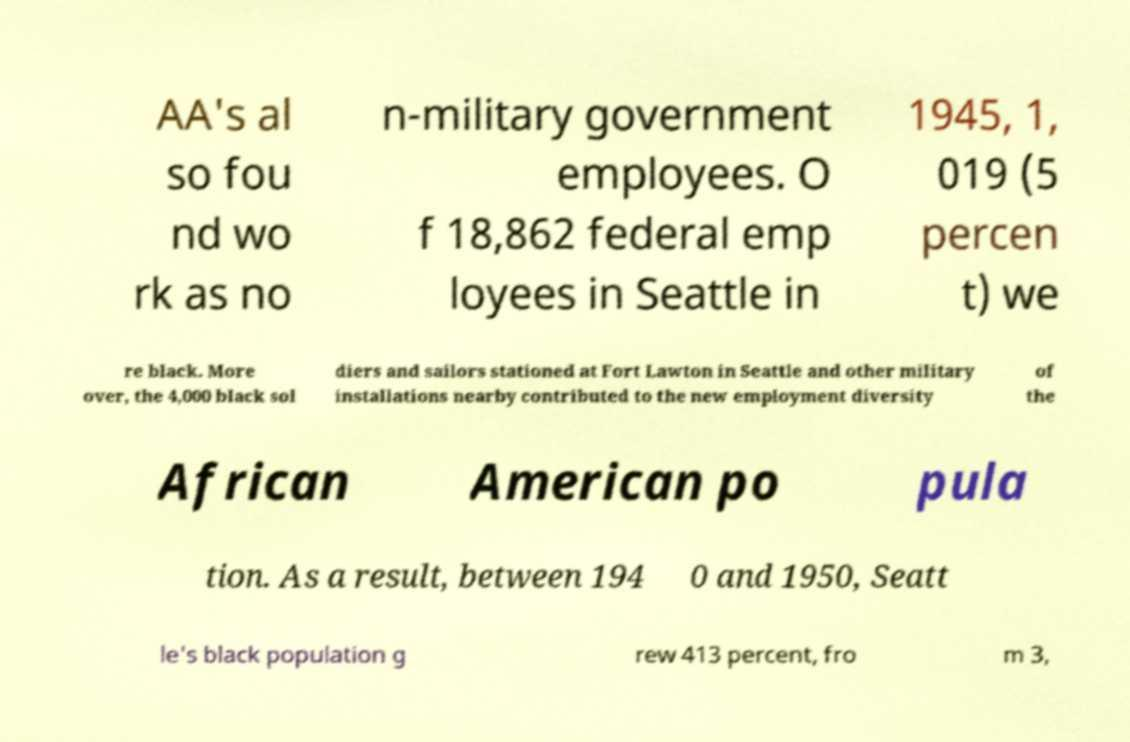I need the written content from this picture converted into text. Can you do that? AA's al so fou nd wo rk as no n-military government employees. O f 18,862 federal emp loyees in Seattle in 1945, 1, 019 (5 percen t) we re black. More over, the 4,000 black sol diers and sailors stationed at Fort Lawton in Seattle and other military installations nearby contributed to the new employment diversity of the African American po pula tion. As a result, between 194 0 and 1950, Seatt le's black population g rew 413 percent, fro m 3, 